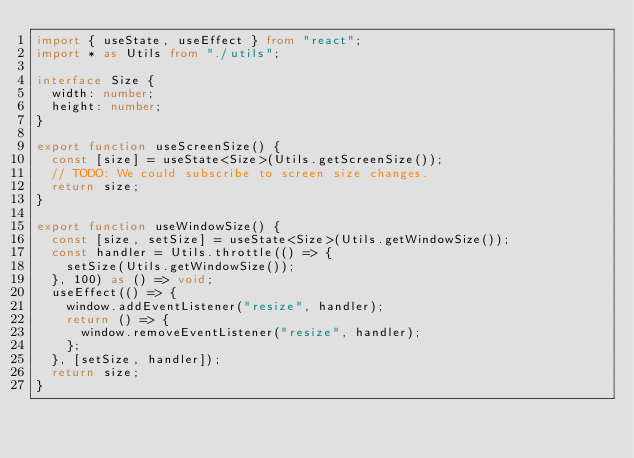Convert code to text. <code><loc_0><loc_0><loc_500><loc_500><_TypeScript_>import { useState, useEffect } from "react";
import * as Utils from "./utils";

interface Size {
  width: number;
  height: number;
}

export function useScreenSize() {
  const [size] = useState<Size>(Utils.getScreenSize());
  // TODO: We could subscribe to screen size changes.
  return size;
}

export function useWindowSize() {
  const [size, setSize] = useState<Size>(Utils.getWindowSize());
  const handler = Utils.throttle(() => {
    setSize(Utils.getWindowSize());
  }, 100) as () => void;
  useEffect(() => {
    window.addEventListener("resize", handler);
    return () => {
      window.removeEventListener("resize", handler);
    };
  }, [setSize, handler]);
  return size;
}
</code> 